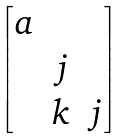<formula> <loc_0><loc_0><loc_500><loc_500>\begin{bmatrix} a & & \\ & j & \\ & k & j \end{bmatrix}</formula> 